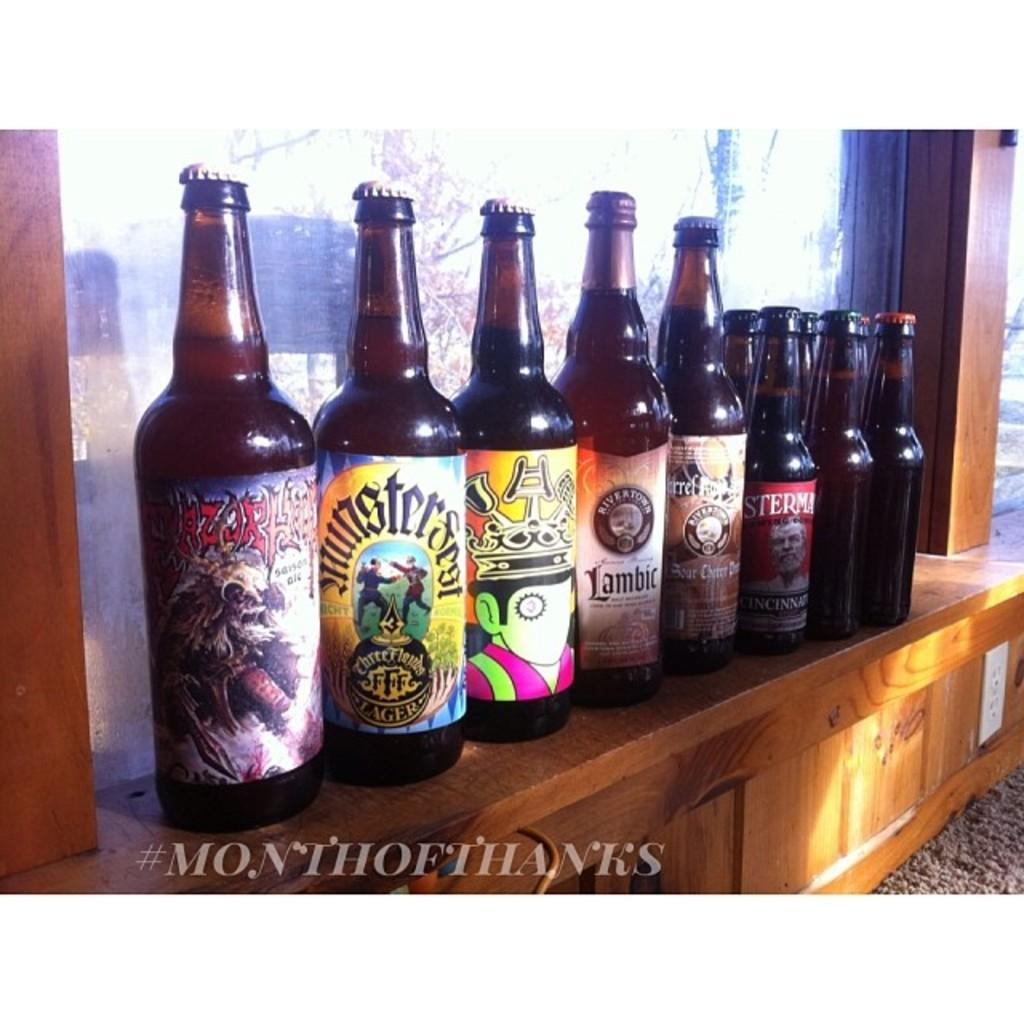<image>
Describe the image concisely. Several bottles of beer with interesting labels, one called Lambic. 